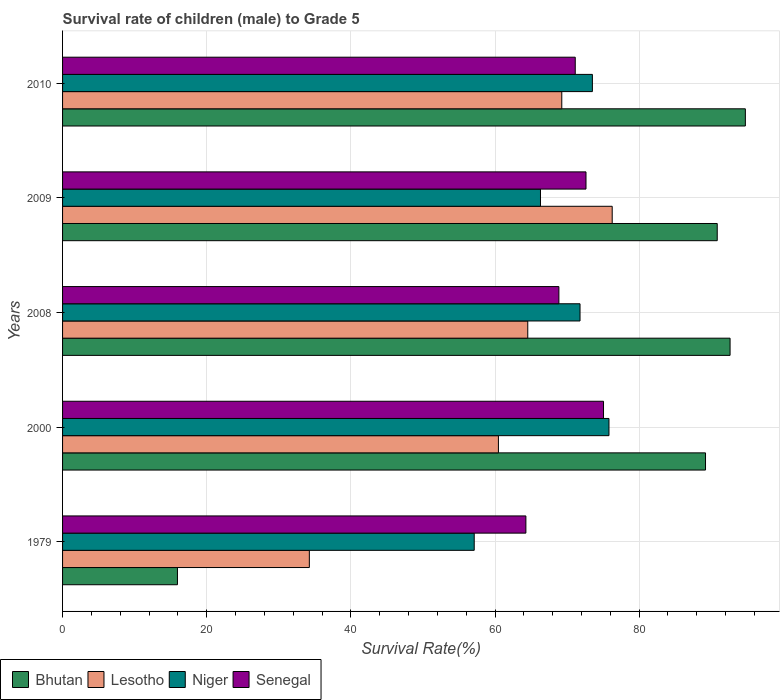How many groups of bars are there?
Offer a very short reply. 5. In how many cases, is the number of bars for a given year not equal to the number of legend labels?
Keep it short and to the point. 0. What is the survival rate of male children to grade 5 in Lesotho in 2010?
Keep it short and to the point. 69.27. Across all years, what is the maximum survival rate of male children to grade 5 in Senegal?
Provide a short and direct response. 75.06. Across all years, what is the minimum survival rate of male children to grade 5 in Senegal?
Offer a very short reply. 64.29. In which year was the survival rate of male children to grade 5 in Senegal minimum?
Offer a terse response. 1979. What is the total survival rate of male children to grade 5 in Lesotho in the graph?
Offer a terse response. 304.79. What is the difference between the survival rate of male children to grade 5 in Senegal in 2008 and that in 2010?
Your answer should be compact. -2.27. What is the difference between the survival rate of male children to grade 5 in Lesotho in 2010 and the survival rate of male children to grade 5 in Niger in 2000?
Provide a succinct answer. -6.55. What is the average survival rate of male children to grade 5 in Lesotho per year?
Give a very brief answer. 60.96. In the year 2009, what is the difference between the survival rate of male children to grade 5 in Senegal and survival rate of male children to grade 5 in Niger?
Offer a very short reply. 6.32. What is the ratio of the survival rate of male children to grade 5 in Senegal in 1979 to that in 2010?
Keep it short and to the point. 0.9. Is the survival rate of male children to grade 5 in Niger in 2009 less than that in 2010?
Make the answer very short. Yes. Is the difference between the survival rate of male children to grade 5 in Senegal in 1979 and 2010 greater than the difference between the survival rate of male children to grade 5 in Niger in 1979 and 2010?
Your response must be concise. Yes. What is the difference between the highest and the second highest survival rate of male children to grade 5 in Lesotho?
Ensure brevity in your answer.  7. What is the difference between the highest and the lowest survival rate of male children to grade 5 in Senegal?
Offer a very short reply. 10.77. Is the sum of the survival rate of male children to grade 5 in Bhutan in 2008 and 2010 greater than the maximum survival rate of male children to grade 5 in Lesotho across all years?
Offer a very short reply. Yes. Is it the case that in every year, the sum of the survival rate of male children to grade 5 in Senegal and survival rate of male children to grade 5 in Niger is greater than the sum of survival rate of male children to grade 5 in Bhutan and survival rate of male children to grade 5 in Lesotho?
Give a very brief answer. No. What does the 2nd bar from the top in 1979 represents?
Your answer should be compact. Niger. What does the 4th bar from the bottom in 1979 represents?
Provide a short and direct response. Senegal. Are all the bars in the graph horizontal?
Your answer should be compact. Yes. How many years are there in the graph?
Keep it short and to the point. 5. What is the difference between two consecutive major ticks on the X-axis?
Offer a very short reply. 20. Are the values on the major ticks of X-axis written in scientific E-notation?
Give a very brief answer. No. Does the graph contain any zero values?
Your answer should be compact. No. Does the graph contain grids?
Your answer should be compact. Yes. What is the title of the graph?
Your response must be concise. Survival rate of children (male) to Grade 5. Does "Burundi" appear as one of the legend labels in the graph?
Make the answer very short. No. What is the label or title of the X-axis?
Offer a terse response. Survival Rate(%). What is the label or title of the Y-axis?
Provide a succinct answer. Years. What is the Survival Rate(%) of Bhutan in 1979?
Provide a succinct answer. 15.94. What is the Survival Rate(%) in Lesotho in 1979?
Your answer should be very brief. 34.24. What is the Survival Rate(%) of Niger in 1979?
Give a very brief answer. 57.12. What is the Survival Rate(%) of Senegal in 1979?
Your answer should be compact. 64.29. What is the Survival Rate(%) in Bhutan in 2000?
Provide a short and direct response. 89.21. What is the Survival Rate(%) in Lesotho in 2000?
Offer a very short reply. 60.48. What is the Survival Rate(%) in Niger in 2000?
Make the answer very short. 75.81. What is the Survival Rate(%) in Senegal in 2000?
Offer a very short reply. 75.06. What is the Survival Rate(%) in Bhutan in 2008?
Keep it short and to the point. 92.62. What is the Survival Rate(%) in Lesotho in 2008?
Make the answer very short. 64.55. What is the Survival Rate(%) in Niger in 2008?
Give a very brief answer. 71.8. What is the Survival Rate(%) of Senegal in 2008?
Give a very brief answer. 68.87. What is the Survival Rate(%) of Bhutan in 2009?
Make the answer very short. 90.83. What is the Survival Rate(%) in Lesotho in 2009?
Provide a short and direct response. 76.26. What is the Survival Rate(%) of Niger in 2009?
Provide a succinct answer. 66.31. What is the Survival Rate(%) in Senegal in 2009?
Keep it short and to the point. 72.63. What is the Survival Rate(%) of Bhutan in 2010?
Provide a succinct answer. 94.74. What is the Survival Rate(%) of Lesotho in 2010?
Offer a very short reply. 69.27. What is the Survival Rate(%) of Niger in 2010?
Your answer should be compact. 73.51. What is the Survival Rate(%) of Senegal in 2010?
Ensure brevity in your answer.  71.13. Across all years, what is the maximum Survival Rate(%) in Bhutan?
Offer a very short reply. 94.74. Across all years, what is the maximum Survival Rate(%) in Lesotho?
Make the answer very short. 76.26. Across all years, what is the maximum Survival Rate(%) of Niger?
Offer a very short reply. 75.81. Across all years, what is the maximum Survival Rate(%) in Senegal?
Offer a very short reply. 75.06. Across all years, what is the minimum Survival Rate(%) of Bhutan?
Your answer should be very brief. 15.94. Across all years, what is the minimum Survival Rate(%) of Lesotho?
Give a very brief answer. 34.24. Across all years, what is the minimum Survival Rate(%) of Niger?
Provide a short and direct response. 57.12. Across all years, what is the minimum Survival Rate(%) in Senegal?
Your answer should be very brief. 64.29. What is the total Survival Rate(%) in Bhutan in the graph?
Give a very brief answer. 383.34. What is the total Survival Rate(%) of Lesotho in the graph?
Give a very brief answer. 304.79. What is the total Survival Rate(%) of Niger in the graph?
Ensure brevity in your answer.  344.55. What is the total Survival Rate(%) in Senegal in the graph?
Your answer should be compact. 351.97. What is the difference between the Survival Rate(%) of Bhutan in 1979 and that in 2000?
Give a very brief answer. -73.27. What is the difference between the Survival Rate(%) in Lesotho in 1979 and that in 2000?
Keep it short and to the point. -26.24. What is the difference between the Survival Rate(%) in Niger in 1979 and that in 2000?
Your response must be concise. -18.7. What is the difference between the Survival Rate(%) in Senegal in 1979 and that in 2000?
Provide a short and direct response. -10.77. What is the difference between the Survival Rate(%) of Bhutan in 1979 and that in 2008?
Provide a short and direct response. -76.68. What is the difference between the Survival Rate(%) of Lesotho in 1979 and that in 2008?
Offer a terse response. -30.31. What is the difference between the Survival Rate(%) of Niger in 1979 and that in 2008?
Provide a succinct answer. -14.68. What is the difference between the Survival Rate(%) in Senegal in 1979 and that in 2008?
Your answer should be compact. -4.58. What is the difference between the Survival Rate(%) of Bhutan in 1979 and that in 2009?
Offer a very short reply. -74.89. What is the difference between the Survival Rate(%) of Lesotho in 1979 and that in 2009?
Offer a very short reply. -42.02. What is the difference between the Survival Rate(%) in Niger in 1979 and that in 2009?
Offer a very short reply. -9.19. What is the difference between the Survival Rate(%) in Senegal in 1979 and that in 2009?
Provide a succinct answer. -8.34. What is the difference between the Survival Rate(%) of Bhutan in 1979 and that in 2010?
Offer a terse response. -78.8. What is the difference between the Survival Rate(%) in Lesotho in 1979 and that in 2010?
Make the answer very short. -35.03. What is the difference between the Survival Rate(%) of Niger in 1979 and that in 2010?
Your answer should be compact. -16.4. What is the difference between the Survival Rate(%) of Senegal in 1979 and that in 2010?
Ensure brevity in your answer.  -6.85. What is the difference between the Survival Rate(%) of Bhutan in 2000 and that in 2008?
Offer a terse response. -3.41. What is the difference between the Survival Rate(%) of Lesotho in 2000 and that in 2008?
Make the answer very short. -4.07. What is the difference between the Survival Rate(%) of Niger in 2000 and that in 2008?
Your response must be concise. 4.02. What is the difference between the Survival Rate(%) of Senegal in 2000 and that in 2008?
Provide a short and direct response. 6.19. What is the difference between the Survival Rate(%) in Bhutan in 2000 and that in 2009?
Make the answer very short. -1.62. What is the difference between the Survival Rate(%) of Lesotho in 2000 and that in 2009?
Ensure brevity in your answer.  -15.79. What is the difference between the Survival Rate(%) of Niger in 2000 and that in 2009?
Ensure brevity in your answer.  9.5. What is the difference between the Survival Rate(%) in Senegal in 2000 and that in 2009?
Offer a terse response. 2.43. What is the difference between the Survival Rate(%) in Bhutan in 2000 and that in 2010?
Keep it short and to the point. -5.53. What is the difference between the Survival Rate(%) of Lesotho in 2000 and that in 2010?
Give a very brief answer. -8.79. What is the difference between the Survival Rate(%) of Niger in 2000 and that in 2010?
Provide a succinct answer. 2.3. What is the difference between the Survival Rate(%) of Senegal in 2000 and that in 2010?
Your answer should be very brief. 3.92. What is the difference between the Survival Rate(%) in Bhutan in 2008 and that in 2009?
Ensure brevity in your answer.  1.78. What is the difference between the Survival Rate(%) of Lesotho in 2008 and that in 2009?
Provide a succinct answer. -11.72. What is the difference between the Survival Rate(%) in Niger in 2008 and that in 2009?
Give a very brief answer. 5.49. What is the difference between the Survival Rate(%) of Senegal in 2008 and that in 2009?
Provide a short and direct response. -3.76. What is the difference between the Survival Rate(%) in Bhutan in 2008 and that in 2010?
Give a very brief answer. -2.12. What is the difference between the Survival Rate(%) of Lesotho in 2008 and that in 2010?
Keep it short and to the point. -4.72. What is the difference between the Survival Rate(%) of Niger in 2008 and that in 2010?
Give a very brief answer. -1.71. What is the difference between the Survival Rate(%) of Senegal in 2008 and that in 2010?
Give a very brief answer. -2.27. What is the difference between the Survival Rate(%) in Bhutan in 2009 and that in 2010?
Your answer should be compact. -3.9. What is the difference between the Survival Rate(%) of Lesotho in 2009 and that in 2010?
Give a very brief answer. 7. What is the difference between the Survival Rate(%) in Niger in 2009 and that in 2010?
Provide a short and direct response. -7.2. What is the difference between the Survival Rate(%) in Senegal in 2009 and that in 2010?
Provide a succinct answer. 1.49. What is the difference between the Survival Rate(%) of Bhutan in 1979 and the Survival Rate(%) of Lesotho in 2000?
Provide a short and direct response. -44.54. What is the difference between the Survival Rate(%) of Bhutan in 1979 and the Survival Rate(%) of Niger in 2000?
Your response must be concise. -59.87. What is the difference between the Survival Rate(%) of Bhutan in 1979 and the Survival Rate(%) of Senegal in 2000?
Your response must be concise. -59.12. What is the difference between the Survival Rate(%) in Lesotho in 1979 and the Survival Rate(%) in Niger in 2000?
Offer a very short reply. -41.57. What is the difference between the Survival Rate(%) of Lesotho in 1979 and the Survival Rate(%) of Senegal in 2000?
Provide a short and direct response. -40.82. What is the difference between the Survival Rate(%) in Niger in 1979 and the Survival Rate(%) in Senegal in 2000?
Your answer should be compact. -17.94. What is the difference between the Survival Rate(%) in Bhutan in 1979 and the Survival Rate(%) in Lesotho in 2008?
Give a very brief answer. -48.61. What is the difference between the Survival Rate(%) of Bhutan in 1979 and the Survival Rate(%) of Niger in 2008?
Your response must be concise. -55.86. What is the difference between the Survival Rate(%) in Bhutan in 1979 and the Survival Rate(%) in Senegal in 2008?
Keep it short and to the point. -52.93. What is the difference between the Survival Rate(%) in Lesotho in 1979 and the Survival Rate(%) in Niger in 2008?
Offer a terse response. -37.56. What is the difference between the Survival Rate(%) in Lesotho in 1979 and the Survival Rate(%) in Senegal in 2008?
Give a very brief answer. -34.62. What is the difference between the Survival Rate(%) of Niger in 1979 and the Survival Rate(%) of Senegal in 2008?
Your answer should be compact. -11.75. What is the difference between the Survival Rate(%) in Bhutan in 1979 and the Survival Rate(%) in Lesotho in 2009?
Ensure brevity in your answer.  -60.32. What is the difference between the Survival Rate(%) of Bhutan in 1979 and the Survival Rate(%) of Niger in 2009?
Make the answer very short. -50.37. What is the difference between the Survival Rate(%) in Bhutan in 1979 and the Survival Rate(%) in Senegal in 2009?
Your answer should be compact. -56.69. What is the difference between the Survival Rate(%) in Lesotho in 1979 and the Survival Rate(%) in Niger in 2009?
Make the answer very short. -32.07. What is the difference between the Survival Rate(%) in Lesotho in 1979 and the Survival Rate(%) in Senegal in 2009?
Offer a very short reply. -38.39. What is the difference between the Survival Rate(%) of Niger in 1979 and the Survival Rate(%) of Senegal in 2009?
Give a very brief answer. -15.51. What is the difference between the Survival Rate(%) in Bhutan in 1979 and the Survival Rate(%) in Lesotho in 2010?
Provide a short and direct response. -53.33. What is the difference between the Survival Rate(%) of Bhutan in 1979 and the Survival Rate(%) of Niger in 2010?
Make the answer very short. -57.57. What is the difference between the Survival Rate(%) of Bhutan in 1979 and the Survival Rate(%) of Senegal in 2010?
Keep it short and to the point. -55.19. What is the difference between the Survival Rate(%) of Lesotho in 1979 and the Survival Rate(%) of Niger in 2010?
Your answer should be very brief. -39.27. What is the difference between the Survival Rate(%) of Lesotho in 1979 and the Survival Rate(%) of Senegal in 2010?
Make the answer very short. -36.89. What is the difference between the Survival Rate(%) in Niger in 1979 and the Survival Rate(%) in Senegal in 2010?
Ensure brevity in your answer.  -14.02. What is the difference between the Survival Rate(%) in Bhutan in 2000 and the Survival Rate(%) in Lesotho in 2008?
Your answer should be compact. 24.66. What is the difference between the Survival Rate(%) of Bhutan in 2000 and the Survival Rate(%) of Niger in 2008?
Give a very brief answer. 17.41. What is the difference between the Survival Rate(%) in Bhutan in 2000 and the Survival Rate(%) in Senegal in 2008?
Keep it short and to the point. 20.34. What is the difference between the Survival Rate(%) in Lesotho in 2000 and the Survival Rate(%) in Niger in 2008?
Provide a succinct answer. -11.32. What is the difference between the Survival Rate(%) of Lesotho in 2000 and the Survival Rate(%) of Senegal in 2008?
Your answer should be compact. -8.39. What is the difference between the Survival Rate(%) of Niger in 2000 and the Survival Rate(%) of Senegal in 2008?
Your response must be concise. 6.95. What is the difference between the Survival Rate(%) in Bhutan in 2000 and the Survival Rate(%) in Lesotho in 2009?
Make the answer very short. 12.95. What is the difference between the Survival Rate(%) in Bhutan in 2000 and the Survival Rate(%) in Niger in 2009?
Provide a succinct answer. 22.9. What is the difference between the Survival Rate(%) of Bhutan in 2000 and the Survival Rate(%) of Senegal in 2009?
Provide a succinct answer. 16.58. What is the difference between the Survival Rate(%) in Lesotho in 2000 and the Survival Rate(%) in Niger in 2009?
Ensure brevity in your answer.  -5.83. What is the difference between the Survival Rate(%) in Lesotho in 2000 and the Survival Rate(%) in Senegal in 2009?
Provide a short and direct response. -12.15. What is the difference between the Survival Rate(%) in Niger in 2000 and the Survival Rate(%) in Senegal in 2009?
Offer a very short reply. 3.19. What is the difference between the Survival Rate(%) in Bhutan in 2000 and the Survival Rate(%) in Lesotho in 2010?
Your answer should be very brief. 19.94. What is the difference between the Survival Rate(%) of Bhutan in 2000 and the Survival Rate(%) of Niger in 2010?
Your answer should be very brief. 15.7. What is the difference between the Survival Rate(%) in Bhutan in 2000 and the Survival Rate(%) in Senegal in 2010?
Make the answer very short. 18.08. What is the difference between the Survival Rate(%) in Lesotho in 2000 and the Survival Rate(%) in Niger in 2010?
Provide a short and direct response. -13.04. What is the difference between the Survival Rate(%) of Lesotho in 2000 and the Survival Rate(%) of Senegal in 2010?
Ensure brevity in your answer.  -10.66. What is the difference between the Survival Rate(%) of Niger in 2000 and the Survival Rate(%) of Senegal in 2010?
Your answer should be compact. 4.68. What is the difference between the Survival Rate(%) of Bhutan in 2008 and the Survival Rate(%) of Lesotho in 2009?
Keep it short and to the point. 16.36. What is the difference between the Survival Rate(%) of Bhutan in 2008 and the Survival Rate(%) of Niger in 2009?
Give a very brief answer. 26.31. What is the difference between the Survival Rate(%) of Bhutan in 2008 and the Survival Rate(%) of Senegal in 2009?
Your answer should be very brief. 19.99. What is the difference between the Survival Rate(%) of Lesotho in 2008 and the Survival Rate(%) of Niger in 2009?
Ensure brevity in your answer.  -1.76. What is the difference between the Survival Rate(%) in Lesotho in 2008 and the Survival Rate(%) in Senegal in 2009?
Give a very brief answer. -8.08. What is the difference between the Survival Rate(%) of Niger in 2008 and the Survival Rate(%) of Senegal in 2009?
Your answer should be very brief. -0.83. What is the difference between the Survival Rate(%) in Bhutan in 2008 and the Survival Rate(%) in Lesotho in 2010?
Offer a terse response. 23.35. What is the difference between the Survival Rate(%) of Bhutan in 2008 and the Survival Rate(%) of Niger in 2010?
Ensure brevity in your answer.  19.1. What is the difference between the Survival Rate(%) in Bhutan in 2008 and the Survival Rate(%) in Senegal in 2010?
Offer a very short reply. 21.48. What is the difference between the Survival Rate(%) of Lesotho in 2008 and the Survival Rate(%) of Niger in 2010?
Offer a very short reply. -8.97. What is the difference between the Survival Rate(%) in Lesotho in 2008 and the Survival Rate(%) in Senegal in 2010?
Your response must be concise. -6.59. What is the difference between the Survival Rate(%) in Niger in 2008 and the Survival Rate(%) in Senegal in 2010?
Give a very brief answer. 0.66. What is the difference between the Survival Rate(%) of Bhutan in 2009 and the Survival Rate(%) of Lesotho in 2010?
Your answer should be very brief. 21.57. What is the difference between the Survival Rate(%) in Bhutan in 2009 and the Survival Rate(%) in Niger in 2010?
Make the answer very short. 17.32. What is the difference between the Survival Rate(%) of Bhutan in 2009 and the Survival Rate(%) of Senegal in 2010?
Provide a short and direct response. 19.7. What is the difference between the Survival Rate(%) of Lesotho in 2009 and the Survival Rate(%) of Niger in 2010?
Your answer should be very brief. 2.75. What is the difference between the Survival Rate(%) in Lesotho in 2009 and the Survival Rate(%) in Senegal in 2010?
Your answer should be compact. 5.13. What is the difference between the Survival Rate(%) in Niger in 2009 and the Survival Rate(%) in Senegal in 2010?
Provide a succinct answer. -4.82. What is the average Survival Rate(%) of Bhutan per year?
Give a very brief answer. 76.67. What is the average Survival Rate(%) of Lesotho per year?
Offer a very short reply. 60.96. What is the average Survival Rate(%) in Niger per year?
Make the answer very short. 68.91. What is the average Survival Rate(%) of Senegal per year?
Give a very brief answer. 70.39. In the year 1979, what is the difference between the Survival Rate(%) in Bhutan and Survival Rate(%) in Lesotho?
Provide a short and direct response. -18.3. In the year 1979, what is the difference between the Survival Rate(%) in Bhutan and Survival Rate(%) in Niger?
Provide a short and direct response. -41.18. In the year 1979, what is the difference between the Survival Rate(%) of Bhutan and Survival Rate(%) of Senegal?
Your answer should be very brief. -48.35. In the year 1979, what is the difference between the Survival Rate(%) of Lesotho and Survival Rate(%) of Niger?
Provide a short and direct response. -22.88. In the year 1979, what is the difference between the Survival Rate(%) of Lesotho and Survival Rate(%) of Senegal?
Your answer should be compact. -30.05. In the year 1979, what is the difference between the Survival Rate(%) of Niger and Survival Rate(%) of Senegal?
Give a very brief answer. -7.17. In the year 2000, what is the difference between the Survival Rate(%) in Bhutan and Survival Rate(%) in Lesotho?
Offer a very short reply. 28.73. In the year 2000, what is the difference between the Survival Rate(%) in Bhutan and Survival Rate(%) in Niger?
Ensure brevity in your answer.  13.4. In the year 2000, what is the difference between the Survival Rate(%) in Bhutan and Survival Rate(%) in Senegal?
Offer a terse response. 14.15. In the year 2000, what is the difference between the Survival Rate(%) in Lesotho and Survival Rate(%) in Niger?
Keep it short and to the point. -15.34. In the year 2000, what is the difference between the Survival Rate(%) in Lesotho and Survival Rate(%) in Senegal?
Your answer should be compact. -14.58. In the year 2000, what is the difference between the Survival Rate(%) in Niger and Survival Rate(%) in Senegal?
Ensure brevity in your answer.  0.76. In the year 2008, what is the difference between the Survival Rate(%) in Bhutan and Survival Rate(%) in Lesotho?
Make the answer very short. 28.07. In the year 2008, what is the difference between the Survival Rate(%) in Bhutan and Survival Rate(%) in Niger?
Offer a very short reply. 20.82. In the year 2008, what is the difference between the Survival Rate(%) of Bhutan and Survival Rate(%) of Senegal?
Offer a terse response. 23.75. In the year 2008, what is the difference between the Survival Rate(%) in Lesotho and Survival Rate(%) in Niger?
Make the answer very short. -7.25. In the year 2008, what is the difference between the Survival Rate(%) in Lesotho and Survival Rate(%) in Senegal?
Provide a succinct answer. -4.32. In the year 2008, what is the difference between the Survival Rate(%) of Niger and Survival Rate(%) of Senegal?
Your response must be concise. 2.93. In the year 2009, what is the difference between the Survival Rate(%) in Bhutan and Survival Rate(%) in Lesotho?
Keep it short and to the point. 14.57. In the year 2009, what is the difference between the Survival Rate(%) of Bhutan and Survival Rate(%) of Niger?
Make the answer very short. 24.52. In the year 2009, what is the difference between the Survival Rate(%) of Bhutan and Survival Rate(%) of Senegal?
Give a very brief answer. 18.21. In the year 2009, what is the difference between the Survival Rate(%) in Lesotho and Survival Rate(%) in Niger?
Give a very brief answer. 9.95. In the year 2009, what is the difference between the Survival Rate(%) in Lesotho and Survival Rate(%) in Senegal?
Keep it short and to the point. 3.63. In the year 2009, what is the difference between the Survival Rate(%) of Niger and Survival Rate(%) of Senegal?
Offer a terse response. -6.32. In the year 2010, what is the difference between the Survival Rate(%) in Bhutan and Survival Rate(%) in Lesotho?
Offer a terse response. 25.47. In the year 2010, what is the difference between the Survival Rate(%) in Bhutan and Survival Rate(%) in Niger?
Provide a short and direct response. 21.22. In the year 2010, what is the difference between the Survival Rate(%) in Bhutan and Survival Rate(%) in Senegal?
Make the answer very short. 23.6. In the year 2010, what is the difference between the Survival Rate(%) of Lesotho and Survival Rate(%) of Niger?
Your response must be concise. -4.25. In the year 2010, what is the difference between the Survival Rate(%) in Lesotho and Survival Rate(%) in Senegal?
Make the answer very short. -1.87. In the year 2010, what is the difference between the Survival Rate(%) of Niger and Survival Rate(%) of Senegal?
Provide a short and direct response. 2.38. What is the ratio of the Survival Rate(%) of Bhutan in 1979 to that in 2000?
Make the answer very short. 0.18. What is the ratio of the Survival Rate(%) in Lesotho in 1979 to that in 2000?
Give a very brief answer. 0.57. What is the ratio of the Survival Rate(%) of Niger in 1979 to that in 2000?
Your response must be concise. 0.75. What is the ratio of the Survival Rate(%) of Senegal in 1979 to that in 2000?
Provide a succinct answer. 0.86. What is the ratio of the Survival Rate(%) of Bhutan in 1979 to that in 2008?
Provide a succinct answer. 0.17. What is the ratio of the Survival Rate(%) of Lesotho in 1979 to that in 2008?
Your response must be concise. 0.53. What is the ratio of the Survival Rate(%) of Niger in 1979 to that in 2008?
Offer a terse response. 0.8. What is the ratio of the Survival Rate(%) in Senegal in 1979 to that in 2008?
Your response must be concise. 0.93. What is the ratio of the Survival Rate(%) of Bhutan in 1979 to that in 2009?
Ensure brevity in your answer.  0.18. What is the ratio of the Survival Rate(%) of Lesotho in 1979 to that in 2009?
Your answer should be compact. 0.45. What is the ratio of the Survival Rate(%) of Niger in 1979 to that in 2009?
Provide a short and direct response. 0.86. What is the ratio of the Survival Rate(%) in Senegal in 1979 to that in 2009?
Make the answer very short. 0.89. What is the ratio of the Survival Rate(%) in Bhutan in 1979 to that in 2010?
Provide a succinct answer. 0.17. What is the ratio of the Survival Rate(%) of Lesotho in 1979 to that in 2010?
Provide a short and direct response. 0.49. What is the ratio of the Survival Rate(%) in Niger in 1979 to that in 2010?
Ensure brevity in your answer.  0.78. What is the ratio of the Survival Rate(%) in Senegal in 1979 to that in 2010?
Ensure brevity in your answer.  0.9. What is the ratio of the Survival Rate(%) of Bhutan in 2000 to that in 2008?
Give a very brief answer. 0.96. What is the ratio of the Survival Rate(%) of Lesotho in 2000 to that in 2008?
Your answer should be compact. 0.94. What is the ratio of the Survival Rate(%) in Niger in 2000 to that in 2008?
Ensure brevity in your answer.  1.06. What is the ratio of the Survival Rate(%) in Senegal in 2000 to that in 2008?
Offer a terse response. 1.09. What is the ratio of the Survival Rate(%) in Bhutan in 2000 to that in 2009?
Your answer should be compact. 0.98. What is the ratio of the Survival Rate(%) in Lesotho in 2000 to that in 2009?
Make the answer very short. 0.79. What is the ratio of the Survival Rate(%) of Niger in 2000 to that in 2009?
Give a very brief answer. 1.14. What is the ratio of the Survival Rate(%) of Senegal in 2000 to that in 2009?
Offer a very short reply. 1.03. What is the ratio of the Survival Rate(%) in Bhutan in 2000 to that in 2010?
Give a very brief answer. 0.94. What is the ratio of the Survival Rate(%) in Lesotho in 2000 to that in 2010?
Your answer should be very brief. 0.87. What is the ratio of the Survival Rate(%) in Niger in 2000 to that in 2010?
Offer a terse response. 1.03. What is the ratio of the Survival Rate(%) in Senegal in 2000 to that in 2010?
Make the answer very short. 1.06. What is the ratio of the Survival Rate(%) in Bhutan in 2008 to that in 2009?
Your answer should be very brief. 1.02. What is the ratio of the Survival Rate(%) of Lesotho in 2008 to that in 2009?
Give a very brief answer. 0.85. What is the ratio of the Survival Rate(%) of Niger in 2008 to that in 2009?
Your answer should be compact. 1.08. What is the ratio of the Survival Rate(%) in Senegal in 2008 to that in 2009?
Ensure brevity in your answer.  0.95. What is the ratio of the Survival Rate(%) of Bhutan in 2008 to that in 2010?
Provide a succinct answer. 0.98. What is the ratio of the Survival Rate(%) in Lesotho in 2008 to that in 2010?
Offer a very short reply. 0.93. What is the ratio of the Survival Rate(%) in Niger in 2008 to that in 2010?
Give a very brief answer. 0.98. What is the ratio of the Survival Rate(%) of Senegal in 2008 to that in 2010?
Offer a very short reply. 0.97. What is the ratio of the Survival Rate(%) of Bhutan in 2009 to that in 2010?
Offer a terse response. 0.96. What is the ratio of the Survival Rate(%) of Lesotho in 2009 to that in 2010?
Ensure brevity in your answer.  1.1. What is the ratio of the Survival Rate(%) in Niger in 2009 to that in 2010?
Your answer should be very brief. 0.9. What is the ratio of the Survival Rate(%) in Senegal in 2009 to that in 2010?
Give a very brief answer. 1.02. What is the difference between the highest and the second highest Survival Rate(%) in Bhutan?
Offer a terse response. 2.12. What is the difference between the highest and the second highest Survival Rate(%) in Lesotho?
Keep it short and to the point. 7. What is the difference between the highest and the second highest Survival Rate(%) of Niger?
Provide a short and direct response. 2.3. What is the difference between the highest and the second highest Survival Rate(%) in Senegal?
Keep it short and to the point. 2.43. What is the difference between the highest and the lowest Survival Rate(%) of Bhutan?
Provide a succinct answer. 78.8. What is the difference between the highest and the lowest Survival Rate(%) in Lesotho?
Offer a terse response. 42.02. What is the difference between the highest and the lowest Survival Rate(%) in Niger?
Your response must be concise. 18.7. What is the difference between the highest and the lowest Survival Rate(%) of Senegal?
Your response must be concise. 10.77. 